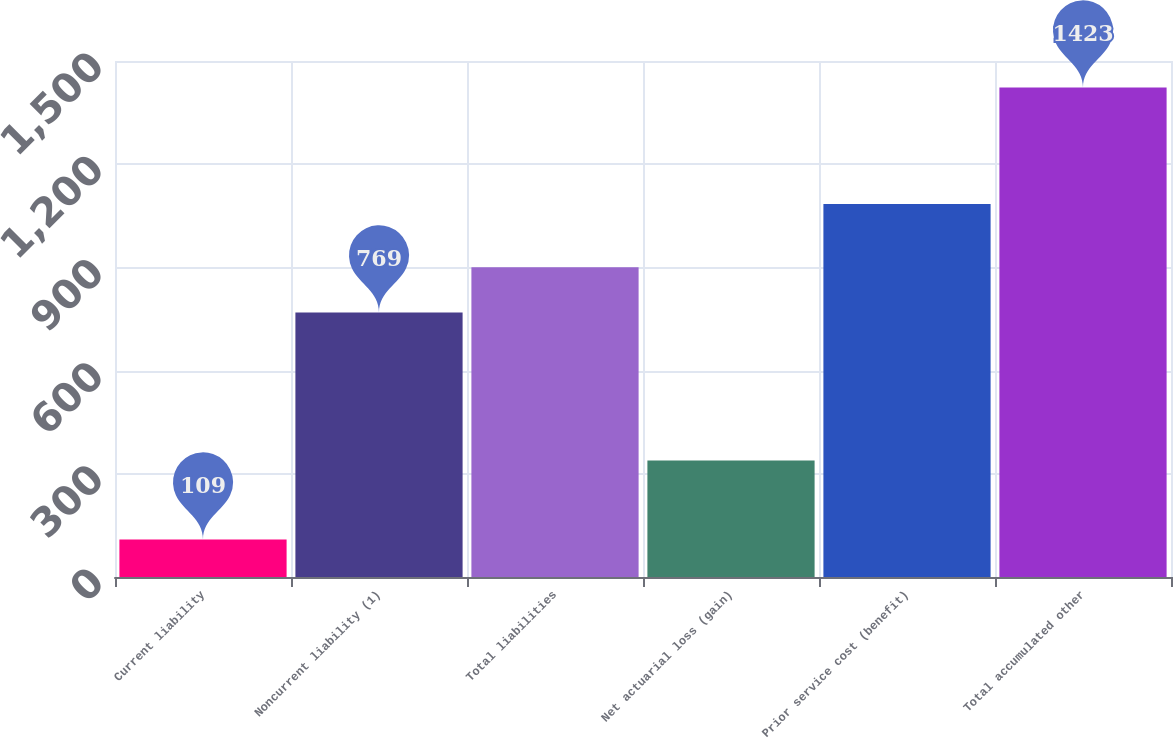Convert chart to OTSL. <chart><loc_0><loc_0><loc_500><loc_500><bar_chart><fcel>Current liability<fcel>Noncurrent liability (1)<fcel>Total liabilities<fcel>Net actuarial loss (gain)<fcel>Prior service cost (benefit)<fcel>Total accumulated other<nl><fcel>109<fcel>769<fcel>900.4<fcel>339<fcel>1084<fcel>1423<nl></chart> 